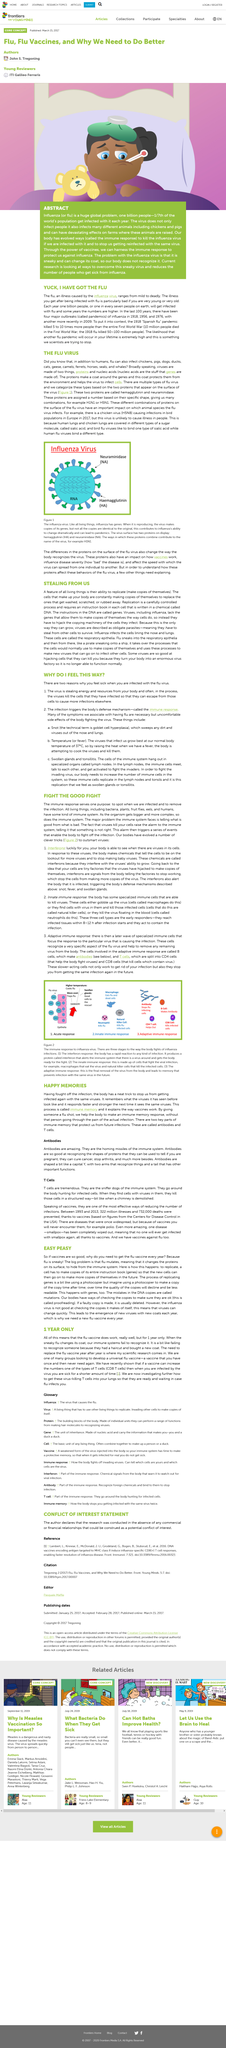Mention a couple of crucial points in this snapshot. Haemagglutinin is a type of protein found on the surface of the influenza virus. The abbreviation HA is commonly used to represent this protein. H1N1 and H5N1 are two examples of flu strains. B cells are responsible for producing antibodies, which are vital for the immune system's defense against infection and disease. The fight against influenza involves three distinct stages. The proteins haemagglutinin and neuraminidase are displayed in the image. 